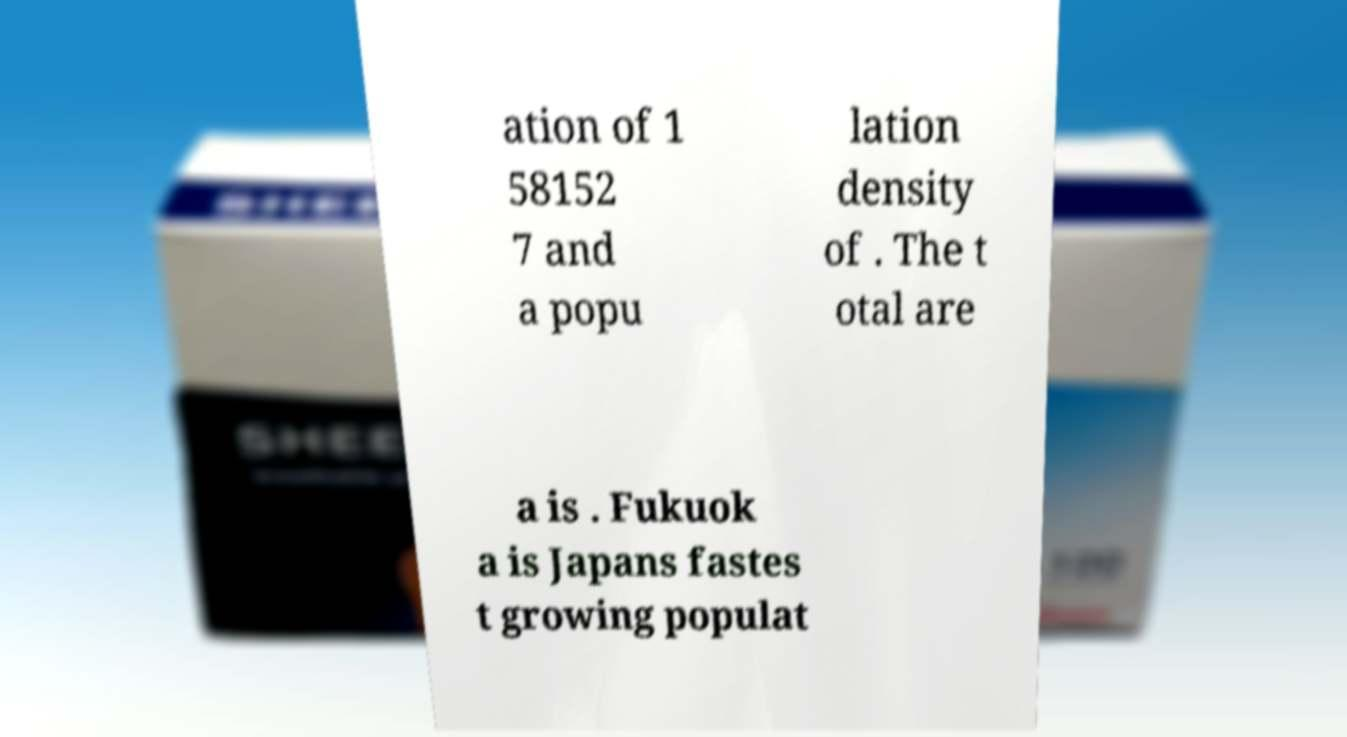What messages or text are displayed in this image? I need them in a readable, typed format. ation of 1 58152 7 and a popu lation density of . The t otal are a is . Fukuok a is Japans fastes t growing populat 